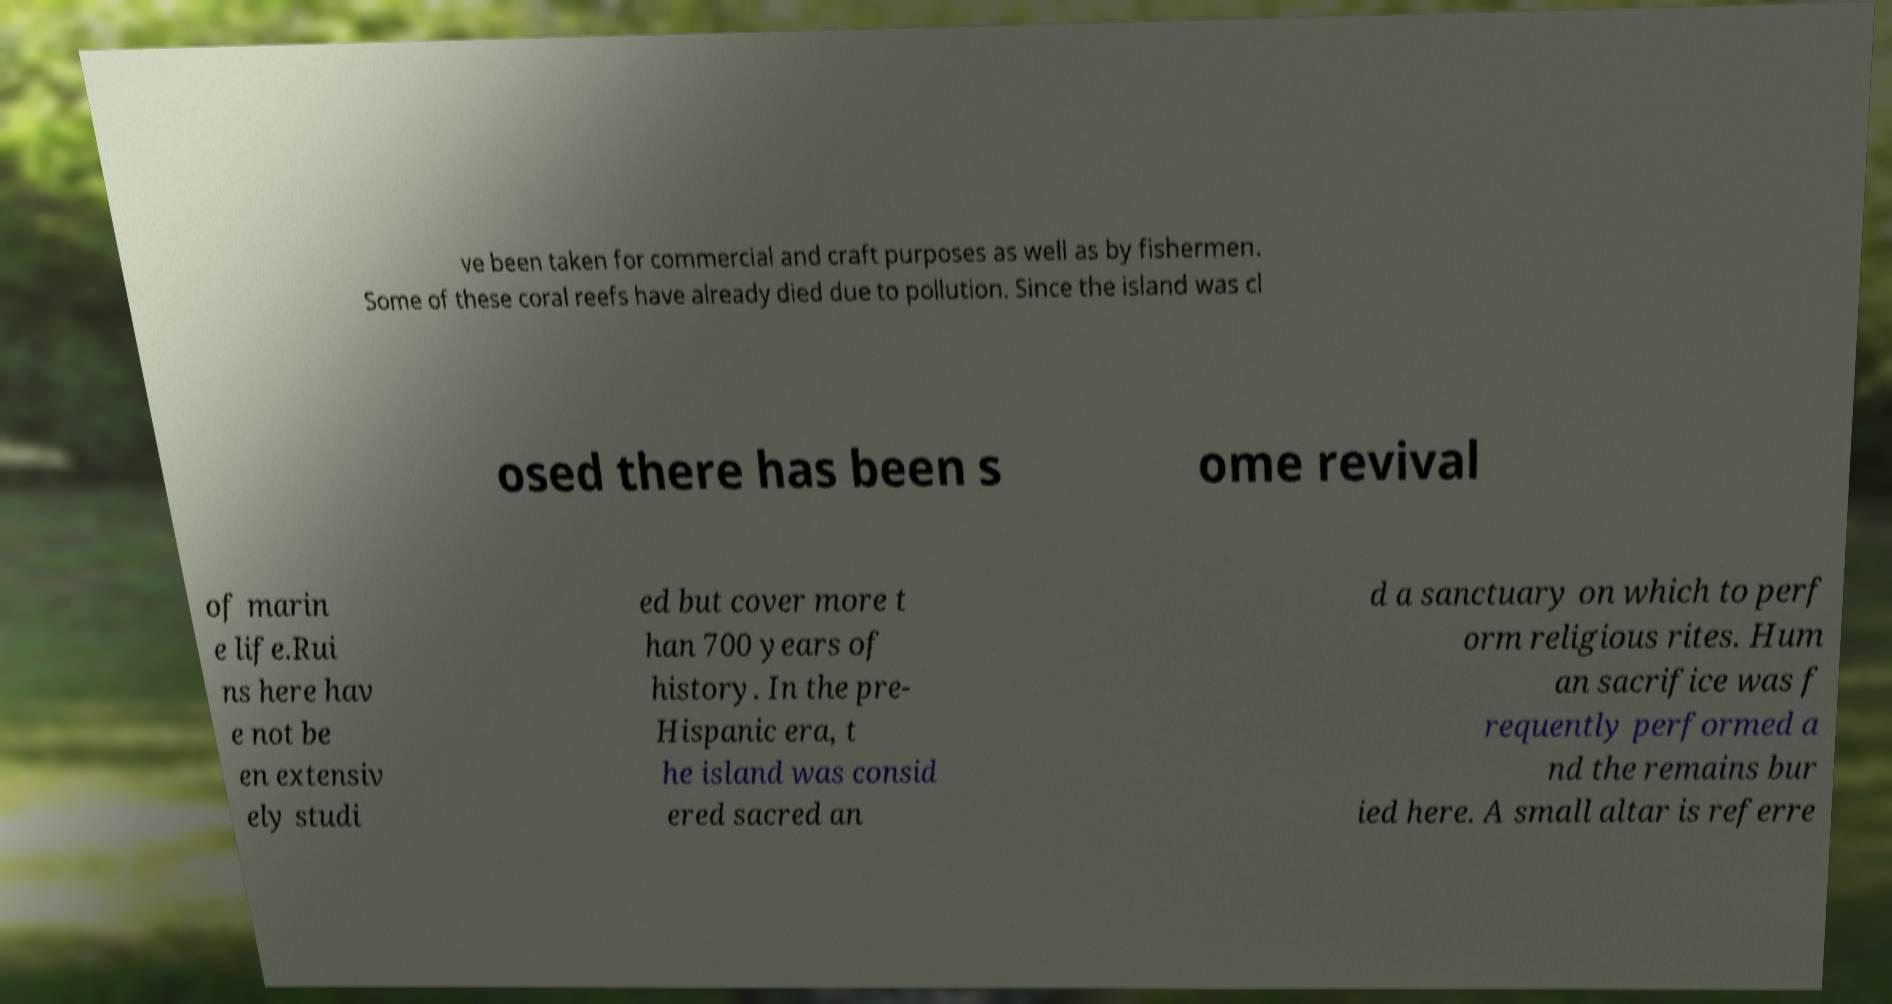Please read and relay the text visible in this image. What does it say? ve been taken for commercial and craft purposes as well as by fishermen. Some of these coral reefs have already died due to pollution. Since the island was cl osed there has been s ome revival of marin e life.Rui ns here hav e not be en extensiv ely studi ed but cover more t han 700 years of history. In the pre- Hispanic era, t he island was consid ered sacred an d a sanctuary on which to perf orm religious rites. Hum an sacrifice was f requently performed a nd the remains bur ied here. A small altar is referre 